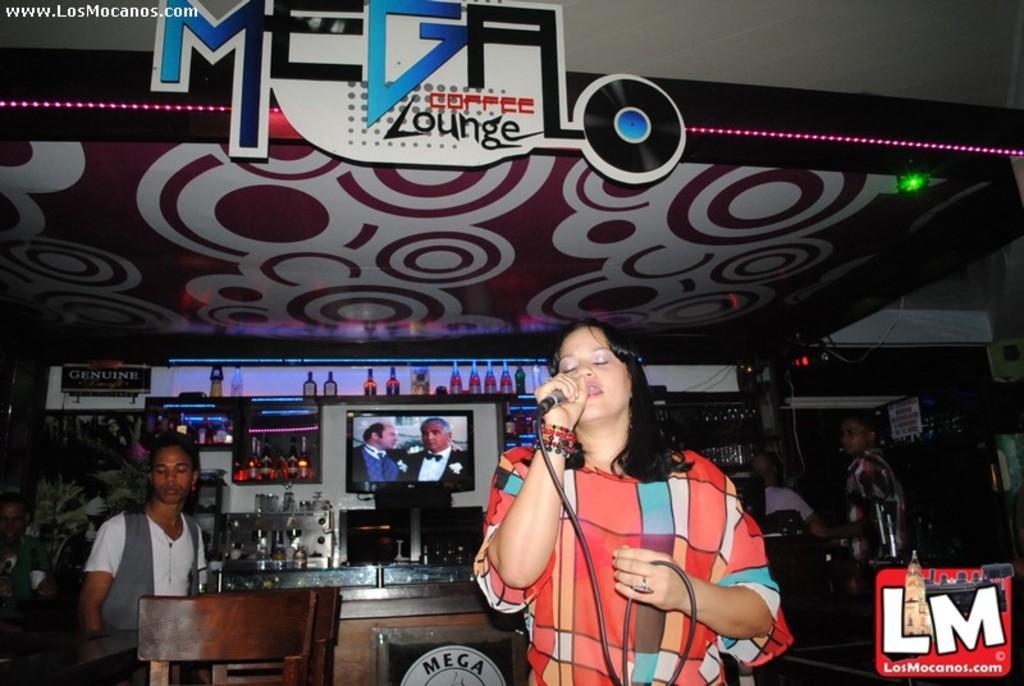In one or two sentences, can you explain what this image depicts? In this picture we can see woman holding mic in her hand and singing and at back of her we can see three men and on table we have glasses, bottles and in background we can see television, bottles on racks, wires, lights, chairs. 